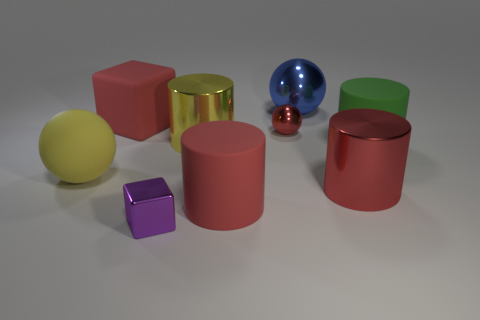Subtract all large yellow cylinders. How many cylinders are left? 3 Subtract 1 cylinders. How many cylinders are left? 3 Subtract all yellow cylinders. Subtract all red balls. How many objects are left? 7 Add 6 big yellow metal things. How many big yellow metal things are left? 7 Add 8 tiny gray metal cubes. How many tiny gray metal cubes exist? 8 Subtract all yellow balls. How many balls are left? 2 Subtract 0 cyan cylinders. How many objects are left? 9 Subtract all blocks. How many objects are left? 7 Subtract all yellow blocks. Subtract all red cylinders. How many blocks are left? 2 Subtract all blue cubes. How many green spheres are left? 0 